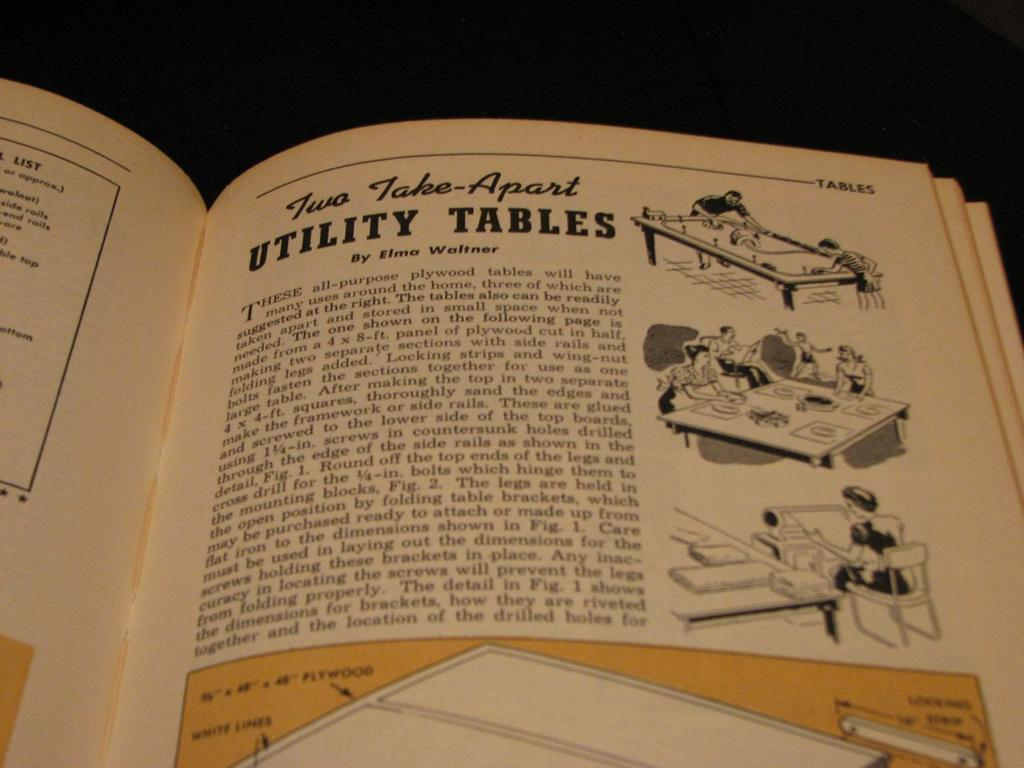<image>
Relay a brief, clear account of the picture shown. A book is open to the chapter " Two Take-Apart Utility Tables". 